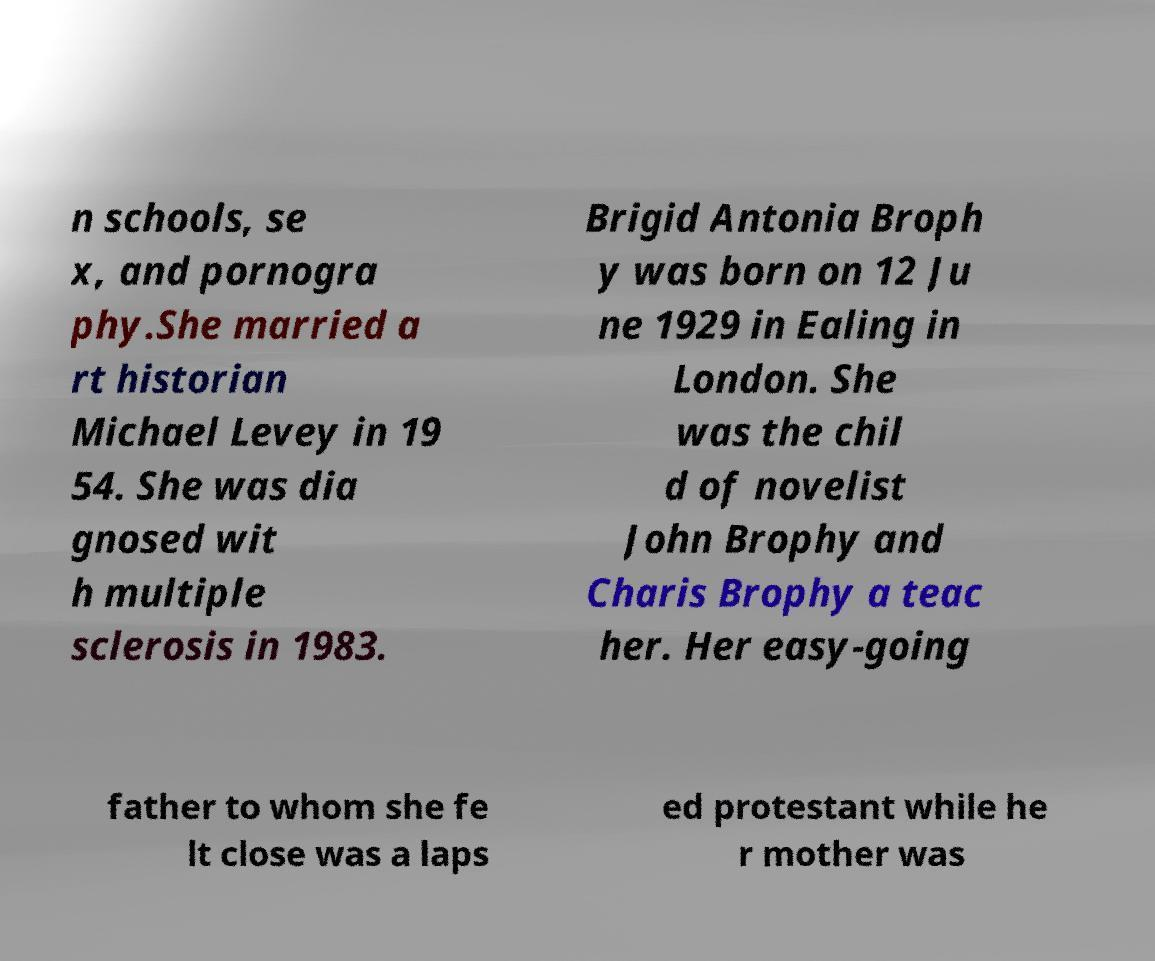Please read and relay the text visible in this image. What does it say? n schools, se x, and pornogra phy.She married a rt historian Michael Levey in 19 54. She was dia gnosed wit h multiple sclerosis in 1983. Brigid Antonia Broph y was born on 12 Ju ne 1929 in Ealing in London. She was the chil d of novelist John Brophy and Charis Brophy a teac her. Her easy-going father to whom she fe lt close was a laps ed protestant while he r mother was 